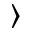<formula> <loc_0><loc_0><loc_500><loc_500>\rangle</formula> 